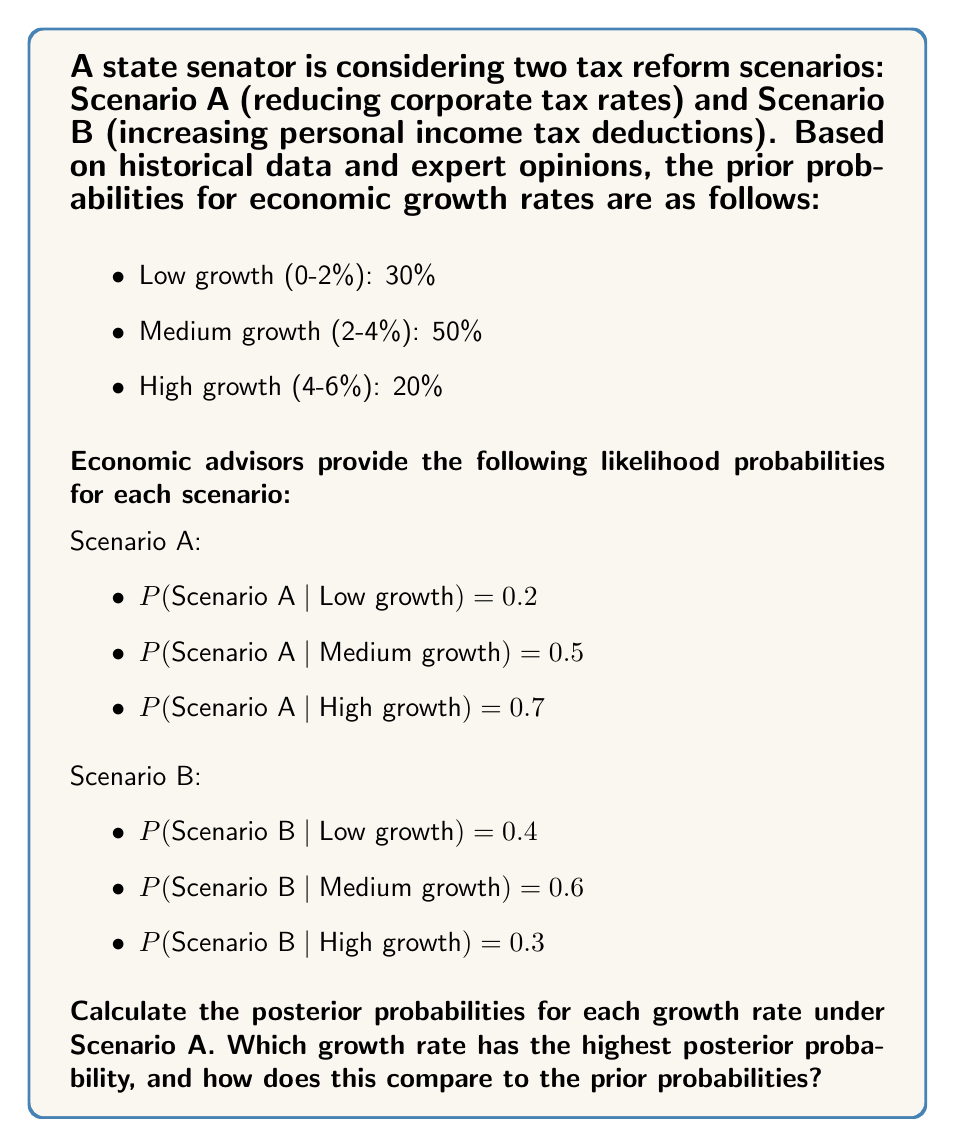Could you help me with this problem? To solve this problem, we'll use Bayes' theorem to calculate the posterior probabilities for each growth rate under Scenario A. The formula for Bayes' theorem is:

$$P(Growth|Scenario A) = \frac{P(Scenario A|Growth) \times P(Growth)}{P(Scenario A)}$$

First, let's calculate P(Scenario A) using the law of total probability:

$$P(Scenario A) = \sum P(Scenario A|Growth_i) \times P(Growth_i)$$

$$P(Scenario A) = 0.2 \times 0.3 + 0.5 \times 0.5 + 0.7 \times 0.2 = 0.45$$

Now, let's calculate the posterior probabilities for each growth rate:

1. Low growth:
   $$P(Low|A) = \frac{0.2 \times 0.3}{0.45} = \frac{0.06}{0.45} = 0.1333$$

2. Medium growth:
   $$P(Medium|A) = \frac{0.5 \times 0.5}{0.45} = \frac{0.25}{0.45} = 0.5556$$

3. High growth:
   $$P(High|A) = \frac{0.7 \times 0.2}{0.45} = \frac{0.14}{0.45} = 0.3111$$

To compare with prior probabilities:

- Low growth: Prior = 30%, Posterior = 13.33%
- Medium growth: Prior = 50%, Posterior = 55.56%
- High growth: Prior = 20%, Posterior = 31.11%
Answer: The growth rate with the highest posterior probability under Scenario A is medium growth (2-4%) at 55.56%. Compared to the prior probabilities, the posterior probability for medium growth increased slightly (from 50% to 55.56%), the probability for high growth increased more substantially (from 20% to 31.11%), while the probability for low growth decreased significantly (from 30% to 13.33%). 